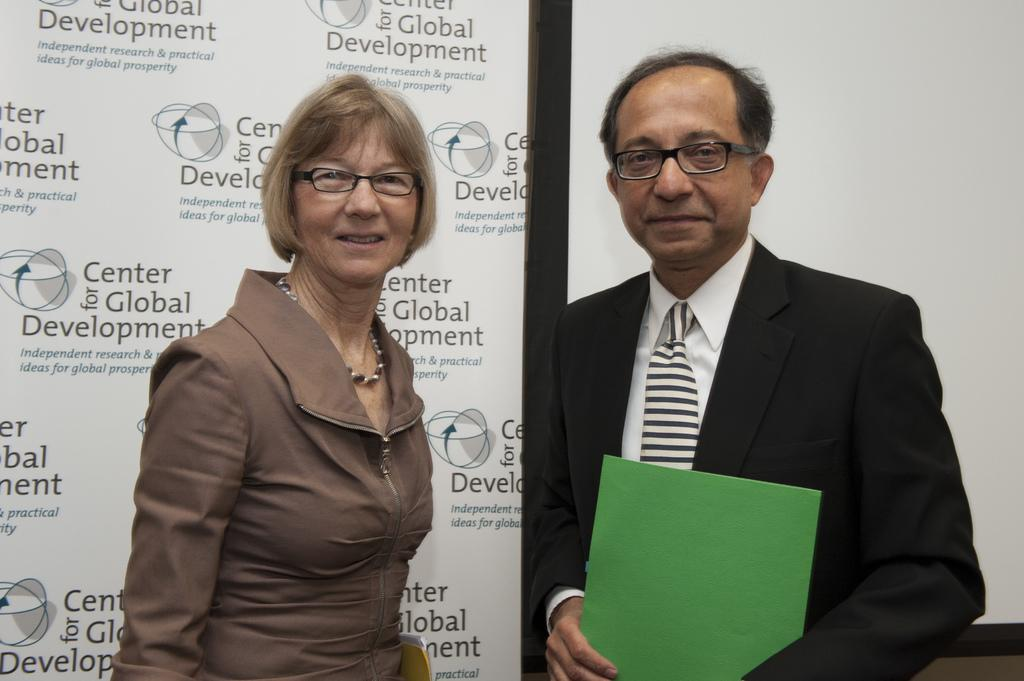How many people are in the image? There are two persons in the image. What are the two persons doing? The two persons are standing and holding papers. What can be seen in the background of the image? There is a board in the background of the image. What is written on the board? There is text on the board. How many cherries are on the board in the image? There are no cherries present in the image. What hope does the text on the board convey? The image does not convey any specific hope, as it only shows two people standing and holding papers, along with a board with text in the background. 